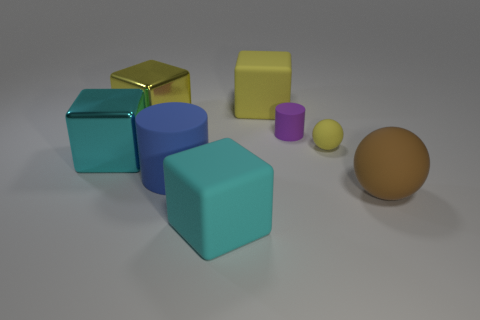Add 1 balls. How many objects exist? 9 Subtract all purple cylinders. How many cylinders are left? 1 Subtract all cylinders. How many objects are left? 6 Subtract 2 blocks. How many blocks are left? 2 Subtract all gray balls. Subtract all purple cubes. How many balls are left? 2 Add 2 red metallic cylinders. How many red metallic cylinders exist? 2 Subtract 0 purple cubes. How many objects are left? 8 Subtract all red cylinders. How many yellow cubes are left? 2 Subtract all small green blocks. Subtract all yellow balls. How many objects are left? 7 Add 7 big metal things. How many big metal things are left? 9 